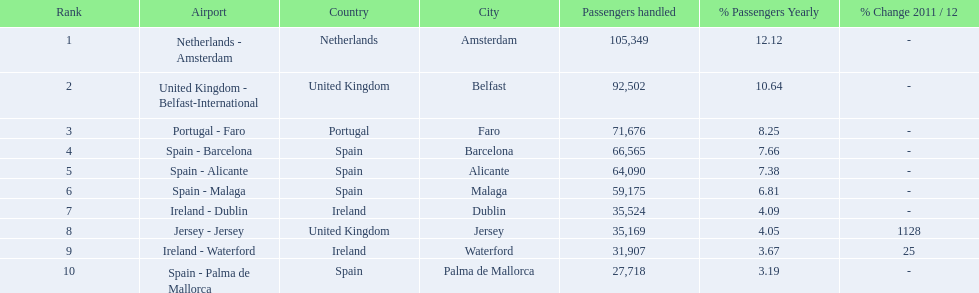What is the highest number of passengers handled? 105,349. What is the destination of the passengers leaving the area that handles 105,349 travellers? Netherlands - Amsterdam. 